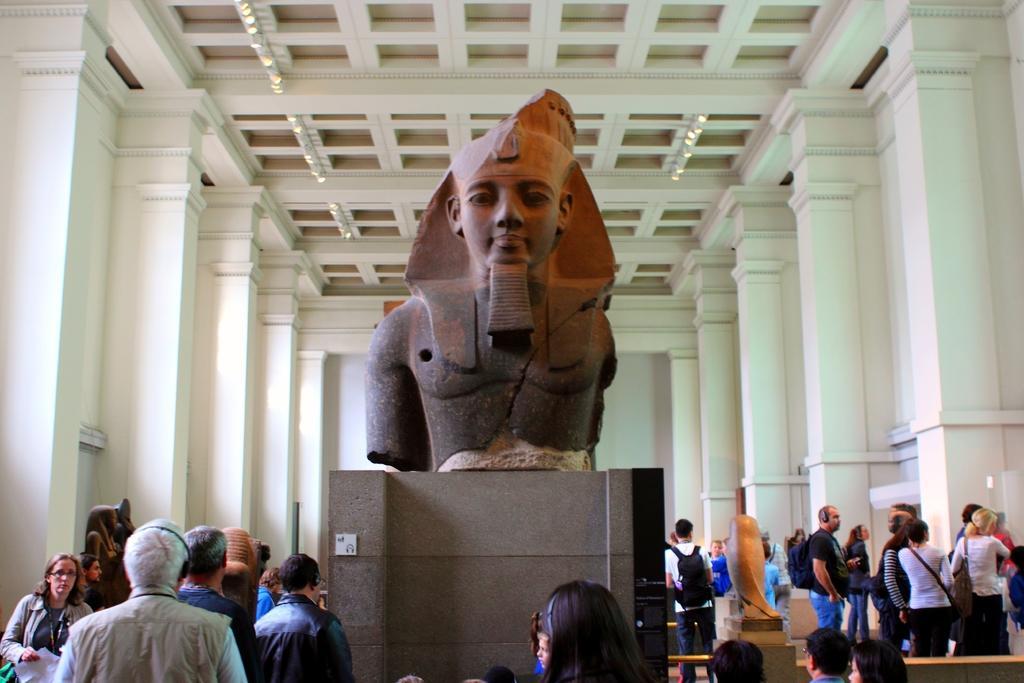Could you give a brief overview of what you see in this image? In the center of the image there is a statue on a concrete platform, around the statue there are a few people in a hall and there are a few other statues as well, in the background of the image there are pillars on the wall, at the top of the image there are lamps on the ceiling. 